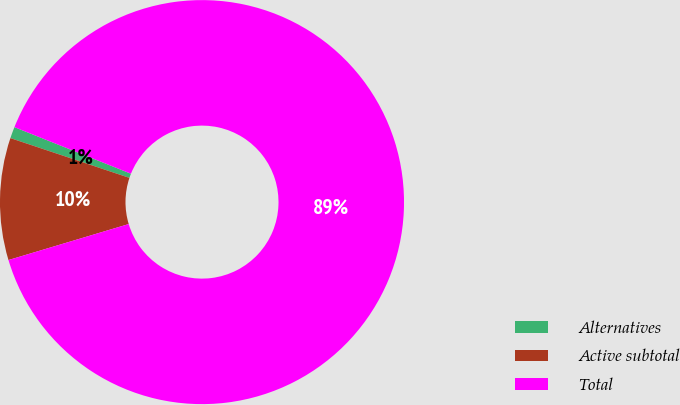<chart> <loc_0><loc_0><loc_500><loc_500><pie_chart><fcel>Alternatives<fcel>Active subtotal<fcel>Total<nl><fcel>0.92%<fcel>9.76%<fcel>89.32%<nl></chart> 